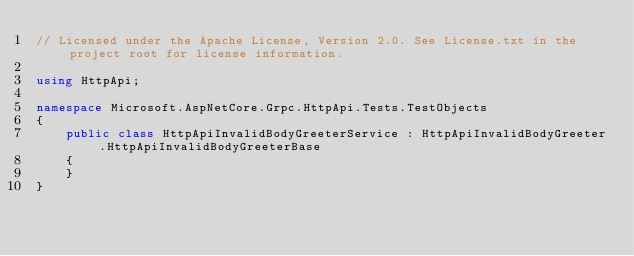Convert code to text. <code><loc_0><loc_0><loc_500><loc_500><_C#_>// Licensed under the Apache License, Version 2.0. See License.txt in the project root for license information.

using HttpApi;

namespace Microsoft.AspNetCore.Grpc.HttpApi.Tests.TestObjects
{
    public class HttpApiInvalidBodyGreeterService : HttpApiInvalidBodyGreeter.HttpApiInvalidBodyGreeterBase
    {
    }
}
</code> 